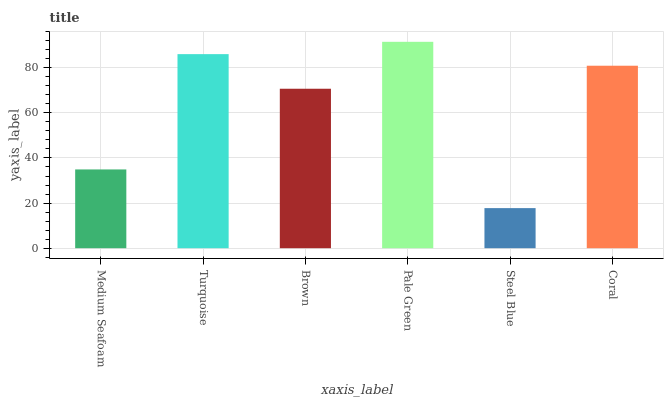Is Steel Blue the minimum?
Answer yes or no. Yes. Is Pale Green the maximum?
Answer yes or no. Yes. Is Turquoise the minimum?
Answer yes or no. No. Is Turquoise the maximum?
Answer yes or no. No. Is Turquoise greater than Medium Seafoam?
Answer yes or no. Yes. Is Medium Seafoam less than Turquoise?
Answer yes or no. Yes. Is Medium Seafoam greater than Turquoise?
Answer yes or no. No. Is Turquoise less than Medium Seafoam?
Answer yes or no. No. Is Coral the high median?
Answer yes or no. Yes. Is Brown the low median?
Answer yes or no. Yes. Is Medium Seafoam the high median?
Answer yes or no. No. Is Medium Seafoam the low median?
Answer yes or no. No. 